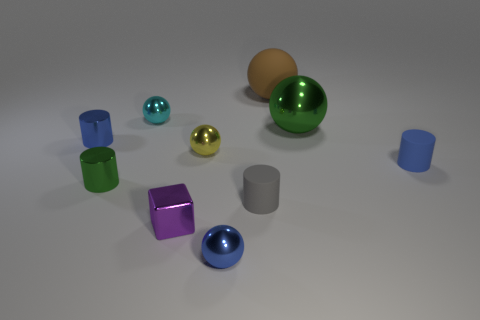Subtract all tiny blue metallic cylinders. How many cylinders are left? 3 Subtract all green cylinders. How many cylinders are left? 3 Subtract all purple cubes. How many green cylinders are left? 1 Subtract all red cubes. Subtract all blue cylinders. How many cubes are left? 1 Subtract all small red shiny balls. Subtract all green metal objects. How many objects are left? 8 Add 6 blue spheres. How many blue spheres are left? 7 Add 8 green metallic objects. How many green metallic objects exist? 10 Subtract 1 cyan spheres. How many objects are left? 9 Subtract all cylinders. How many objects are left? 6 Subtract 1 blocks. How many blocks are left? 0 